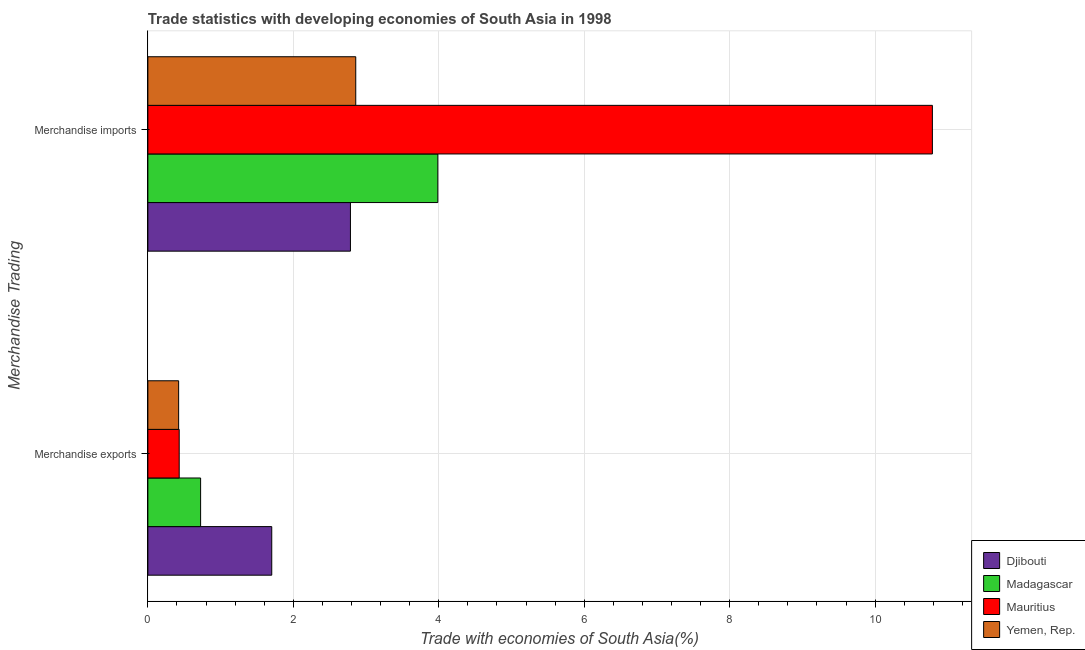How many groups of bars are there?
Provide a succinct answer. 2. Are the number of bars per tick equal to the number of legend labels?
Give a very brief answer. Yes. How many bars are there on the 2nd tick from the top?
Offer a terse response. 4. What is the label of the 1st group of bars from the top?
Keep it short and to the point. Merchandise imports. What is the merchandise imports in Madagascar?
Make the answer very short. 3.99. Across all countries, what is the maximum merchandise exports?
Provide a short and direct response. 1.7. Across all countries, what is the minimum merchandise exports?
Ensure brevity in your answer.  0.42. In which country was the merchandise imports maximum?
Offer a terse response. Mauritius. In which country was the merchandise exports minimum?
Provide a short and direct response. Yemen, Rep. What is the total merchandise exports in the graph?
Your answer should be compact. 3.28. What is the difference between the merchandise exports in Yemen, Rep. and that in Mauritius?
Provide a short and direct response. -0.01. What is the difference between the merchandise exports in Djibouti and the merchandise imports in Yemen, Rep.?
Your response must be concise. -1.16. What is the average merchandise imports per country?
Your response must be concise. 5.1. What is the difference between the merchandise exports and merchandise imports in Djibouti?
Offer a terse response. -1.08. What is the ratio of the merchandise imports in Djibouti to that in Madagascar?
Offer a terse response. 0.7. What does the 3rd bar from the top in Merchandise imports represents?
Offer a terse response. Madagascar. What does the 3rd bar from the bottom in Merchandise exports represents?
Offer a very short reply. Mauritius. How many bars are there?
Ensure brevity in your answer.  8. Are all the bars in the graph horizontal?
Your response must be concise. Yes. How many countries are there in the graph?
Make the answer very short. 4. What is the difference between two consecutive major ticks on the X-axis?
Offer a very short reply. 2. How many legend labels are there?
Ensure brevity in your answer.  4. What is the title of the graph?
Offer a very short reply. Trade statistics with developing economies of South Asia in 1998. Does "Sudan" appear as one of the legend labels in the graph?
Offer a terse response. No. What is the label or title of the X-axis?
Provide a short and direct response. Trade with economies of South Asia(%). What is the label or title of the Y-axis?
Offer a very short reply. Merchandise Trading. What is the Trade with economies of South Asia(%) of Djibouti in Merchandise exports?
Keep it short and to the point. 1.7. What is the Trade with economies of South Asia(%) of Madagascar in Merchandise exports?
Keep it short and to the point. 0.73. What is the Trade with economies of South Asia(%) of Mauritius in Merchandise exports?
Your answer should be compact. 0.43. What is the Trade with economies of South Asia(%) of Yemen, Rep. in Merchandise exports?
Ensure brevity in your answer.  0.42. What is the Trade with economies of South Asia(%) in Djibouti in Merchandise imports?
Offer a very short reply. 2.79. What is the Trade with economies of South Asia(%) in Madagascar in Merchandise imports?
Your answer should be very brief. 3.99. What is the Trade with economies of South Asia(%) in Mauritius in Merchandise imports?
Keep it short and to the point. 10.79. What is the Trade with economies of South Asia(%) of Yemen, Rep. in Merchandise imports?
Your answer should be compact. 2.86. Across all Merchandise Trading, what is the maximum Trade with economies of South Asia(%) in Djibouti?
Make the answer very short. 2.79. Across all Merchandise Trading, what is the maximum Trade with economies of South Asia(%) of Madagascar?
Your answer should be compact. 3.99. Across all Merchandise Trading, what is the maximum Trade with economies of South Asia(%) of Mauritius?
Keep it short and to the point. 10.79. Across all Merchandise Trading, what is the maximum Trade with economies of South Asia(%) of Yemen, Rep.?
Keep it short and to the point. 2.86. Across all Merchandise Trading, what is the minimum Trade with economies of South Asia(%) of Djibouti?
Your answer should be compact. 1.7. Across all Merchandise Trading, what is the minimum Trade with economies of South Asia(%) in Madagascar?
Make the answer very short. 0.73. Across all Merchandise Trading, what is the minimum Trade with economies of South Asia(%) of Mauritius?
Your response must be concise. 0.43. Across all Merchandise Trading, what is the minimum Trade with economies of South Asia(%) in Yemen, Rep.?
Offer a very short reply. 0.42. What is the total Trade with economies of South Asia(%) of Djibouti in the graph?
Your response must be concise. 4.49. What is the total Trade with economies of South Asia(%) of Madagascar in the graph?
Keep it short and to the point. 4.71. What is the total Trade with economies of South Asia(%) in Mauritius in the graph?
Your answer should be compact. 11.22. What is the total Trade with economies of South Asia(%) of Yemen, Rep. in the graph?
Your answer should be compact. 3.28. What is the difference between the Trade with economies of South Asia(%) of Djibouti in Merchandise exports and that in Merchandise imports?
Your response must be concise. -1.08. What is the difference between the Trade with economies of South Asia(%) of Madagascar in Merchandise exports and that in Merchandise imports?
Ensure brevity in your answer.  -3.26. What is the difference between the Trade with economies of South Asia(%) of Mauritius in Merchandise exports and that in Merchandise imports?
Give a very brief answer. -10.36. What is the difference between the Trade with economies of South Asia(%) of Yemen, Rep. in Merchandise exports and that in Merchandise imports?
Your answer should be compact. -2.44. What is the difference between the Trade with economies of South Asia(%) of Djibouti in Merchandise exports and the Trade with economies of South Asia(%) of Madagascar in Merchandise imports?
Make the answer very short. -2.28. What is the difference between the Trade with economies of South Asia(%) of Djibouti in Merchandise exports and the Trade with economies of South Asia(%) of Mauritius in Merchandise imports?
Provide a succinct answer. -9.08. What is the difference between the Trade with economies of South Asia(%) of Djibouti in Merchandise exports and the Trade with economies of South Asia(%) of Yemen, Rep. in Merchandise imports?
Ensure brevity in your answer.  -1.16. What is the difference between the Trade with economies of South Asia(%) of Madagascar in Merchandise exports and the Trade with economies of South Asia(%) of Mauritius in Merchandise imports?
Keep it short and to the point. -10.06. What is the difference between the Trade with economies of South Asia(%) in Madagascar in Merchandise exports and the Trade with economies of South Asia(%) in Yemen, Rep. in Merchandise imports?
Offer a very short reply. -2.13. What is the difference between the Trade with economies of South Asia(%) of Mauritius in Merchandise exports and the Trade with economies of South Asia(%) of Yemen, Rep. in Merchandise imports?
Your answer should be compact. -2.43. What is the average Trade with economies of South Asia(%) in Djibouti per Merchandise Trading?
Provide a succinct answer. 2.24. What is the average Trade with economies of South Asia(%) in Madagascar per Merchandise Trading?
Offer a terse response. 2.36. What is the average Trade with economies of South Asia(%) of Mauritius per Merchandise Trading?
Ensure brevity in your answer.  5.61. What is the average Trade with economies of South Asia(%) of Yemen, Rep. per Merchandise Trading?
Provide a succinct answer. 1.64. What is the difference between the Trade with economies of South Asia(%) in Djibouti and Trade with economies of South Asia(%) in Madagascar in Merchandise exports?
Give a very brief answer. 0.98. What is the difference between the Trade with economies of South Asia(%) of Djibouti and Trade with economies of South Asia(%) of Mauritius in Merchandise exports?
Ensure brevity in your answer.  1.27. What is the difference between the Trade with economies of South Asia(%) of Djibouti and Trade with economies of South Asia(%) of Yemen, Rep. in Merchandise exports?
Your response must be concise. 1.28. What is the difference between the Trade with economies of South Asia(%) of Madagascar and Trade with economies of South Asia(%) of Mauritius in Merchandise exports?
Provide a short and direct response. 0.29. What is the difference between the Trade with economies of South Asia(%) of Madagascar and Trade with economies of South Asia(%) of Yemen, Rep. in Merchandise exports?
Provide a succinct answer. 0.3. What is the difference between the Trade with economies of South Asia(%) of Mauritius and Trade with economies of South Asia(%) of Yemen, Rep. in Merchandise exports?
Provide a short and direct response. 0.01. What is the difference between the Trade with economies of South Asia(%) of Djibouti and Trade with economies of South Asia(%) of Madagascar in Merchandise imports?
Ensure brevity in your answer.  -1.2. What is the difference between the Trade with economies of South Asia(%) in Djibouti and Trade with economies of South Asia(%) in Mauritius in Merchandise imports?
Make the answer very short. -8. What is the difference between the Trade with economies of South Asia(%) in Djibouti and Trade with economies of South Asia(%) in Yemen, Rep. in Merchandise imports?
Make the answer very short. -0.07. What is the difference between the Trade with economies of South Asia(%) in Madagascar and Trade with economies of South Asia(%) in Mauritius in Merchandise imports?
Your answer should be compact. -6.8. What is the difference between the Trade with economies of South Asia(%) in Madagascar and Trade with economies of South Asia(%) in Yemen, Rep. in Merchandise imports?
Your answer should be very brief. 1.13. What is the difference between the Trade with economies of South Asia(%) of Mauritius and Trade with economies of South Asia(%) of Yemen, Rep. in Merchandise imports?
Offer a terse response. 7.93. What is the ratio of the Trade with economies of South Asia(%) in Djibouti in Merchandise exports to that in Merchandise imports?
Offer a very short reply. 0.61. What is the ratio of the Trade with economies of South Asia(%) in Madagascar in Merchandise exports to that in Merchandise imports?
Provide a succinct answer. 0.18. What is the ratio of the Trade with economies of South Asia(%) of Mauritius in Merchandise exports to that in Merchandise imports?
Your answer should be compact. 0.04. What is the ratio of the Trade with economies of South Asia(%) of Yemen, Rep. in Merchandise exports to that in Merchandise imports?
Provide a succinct answer. 0.15. What is the difference between the highest and the second highest Trade with economies of South Asia(%) of Djibouti?
Make the answer very short. 1.08. What is the difference between the highest and the second highest Trade with economies of South Asia(%) in Madagascar?
Provide a short and direct response. 3.26. What is the difference between the highest and the second highest Trade with economies of South Asia(%) in Mauritius?
Give a very brief answer. 10.36. What is the difference between the highest and the second highest Trade with economies of South Asia(%) of Yemen, Rep.?
Give a very brief answer. 2.44. What is the difference between the highest and the lowest Trade with economies of South Asia(%) of Djibouti?
Your response must be concise. 1.08. What is the difference between the highest and the lowest Trade with economies of South Asia(%) in Madagascar?
Your answer should be compact. 3.26. What is the difference between the highest and the lowest Trade with economies of South Asia(%) in Mauritius?
Keep it short and to the point. 10.36. What is the difference between the highest and the lowest Trade with economies of South Asia(%) of Yemen, Rep.?
Your answer should be compact. 2.44. 